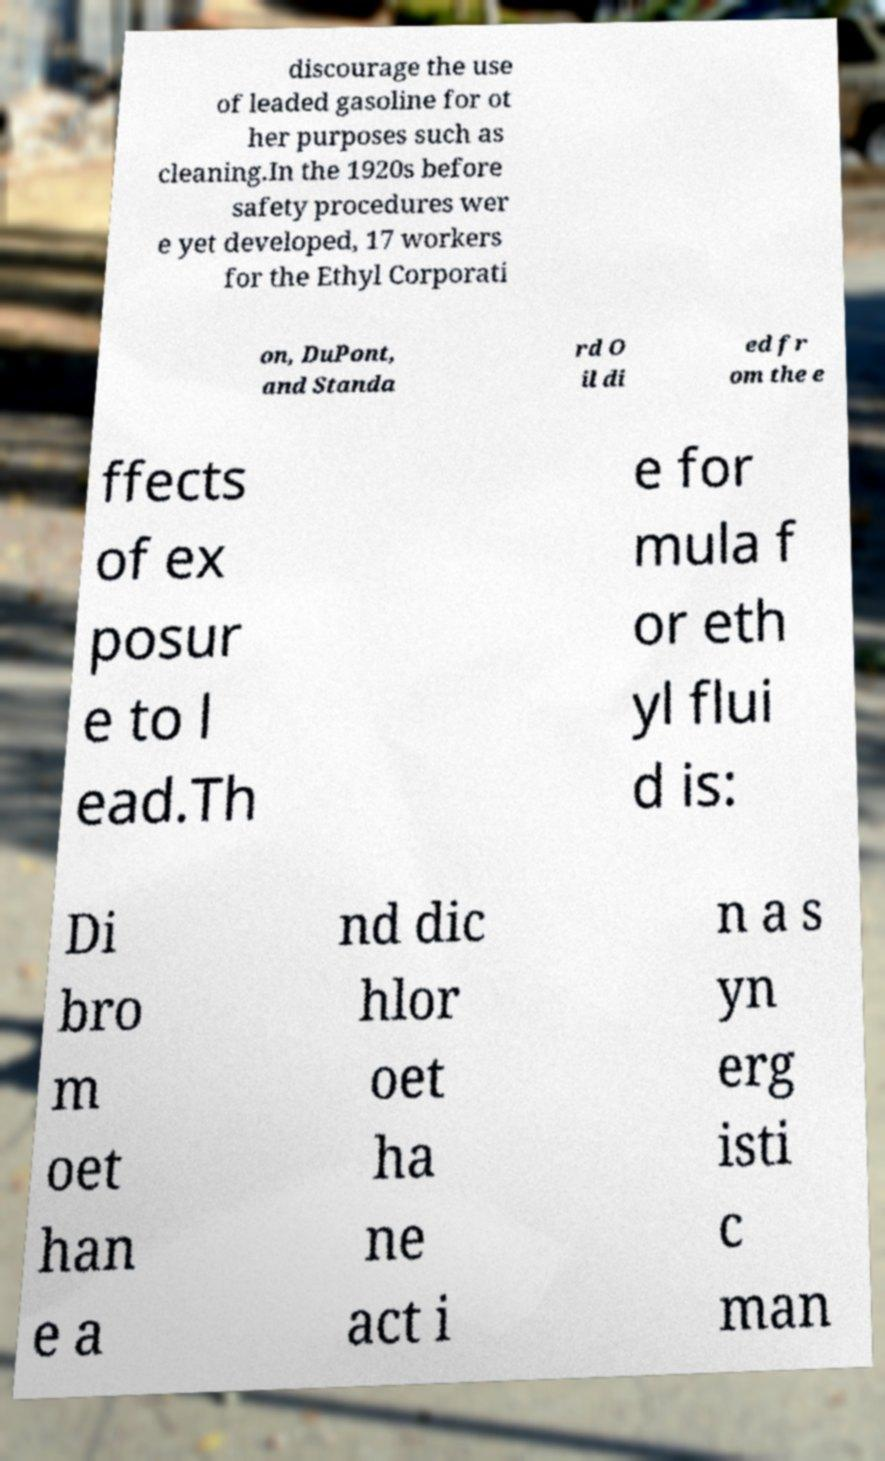Please read and relay the text visible in this image. What does it say? discourage the use of leaded gasoline for ot her purposes such as cleaning.In the 1920s before safety procedures wer e yet developed, 17 workers for the Ethyl Corporati on, DuPont, and Standa rd O il di ed fr om the e ffects of ex posur e to l ead.Th e for mula f or eth yl flui d is: Di bro m oet han e a nd dic hlor oet ha ne act i n a s yn erg isti c man 